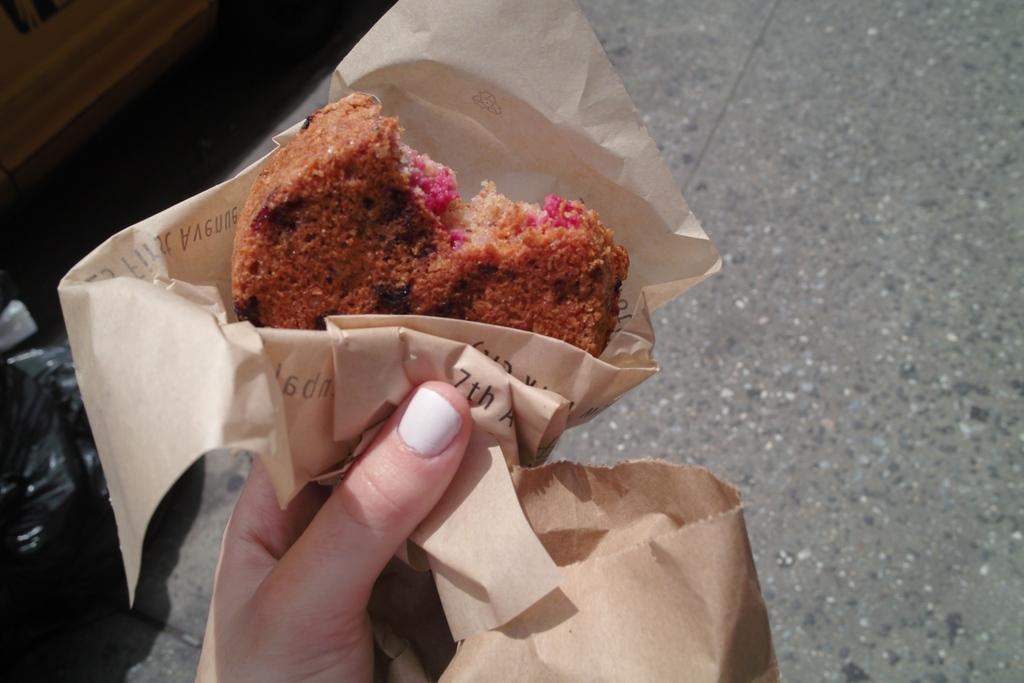Please provide a concise description of this image. In this image, we can see a human hand is holding a food item with paper. At the bottom, we can see a carry bag. Background there is road. Left side of the image, we can see black cover and some object. 